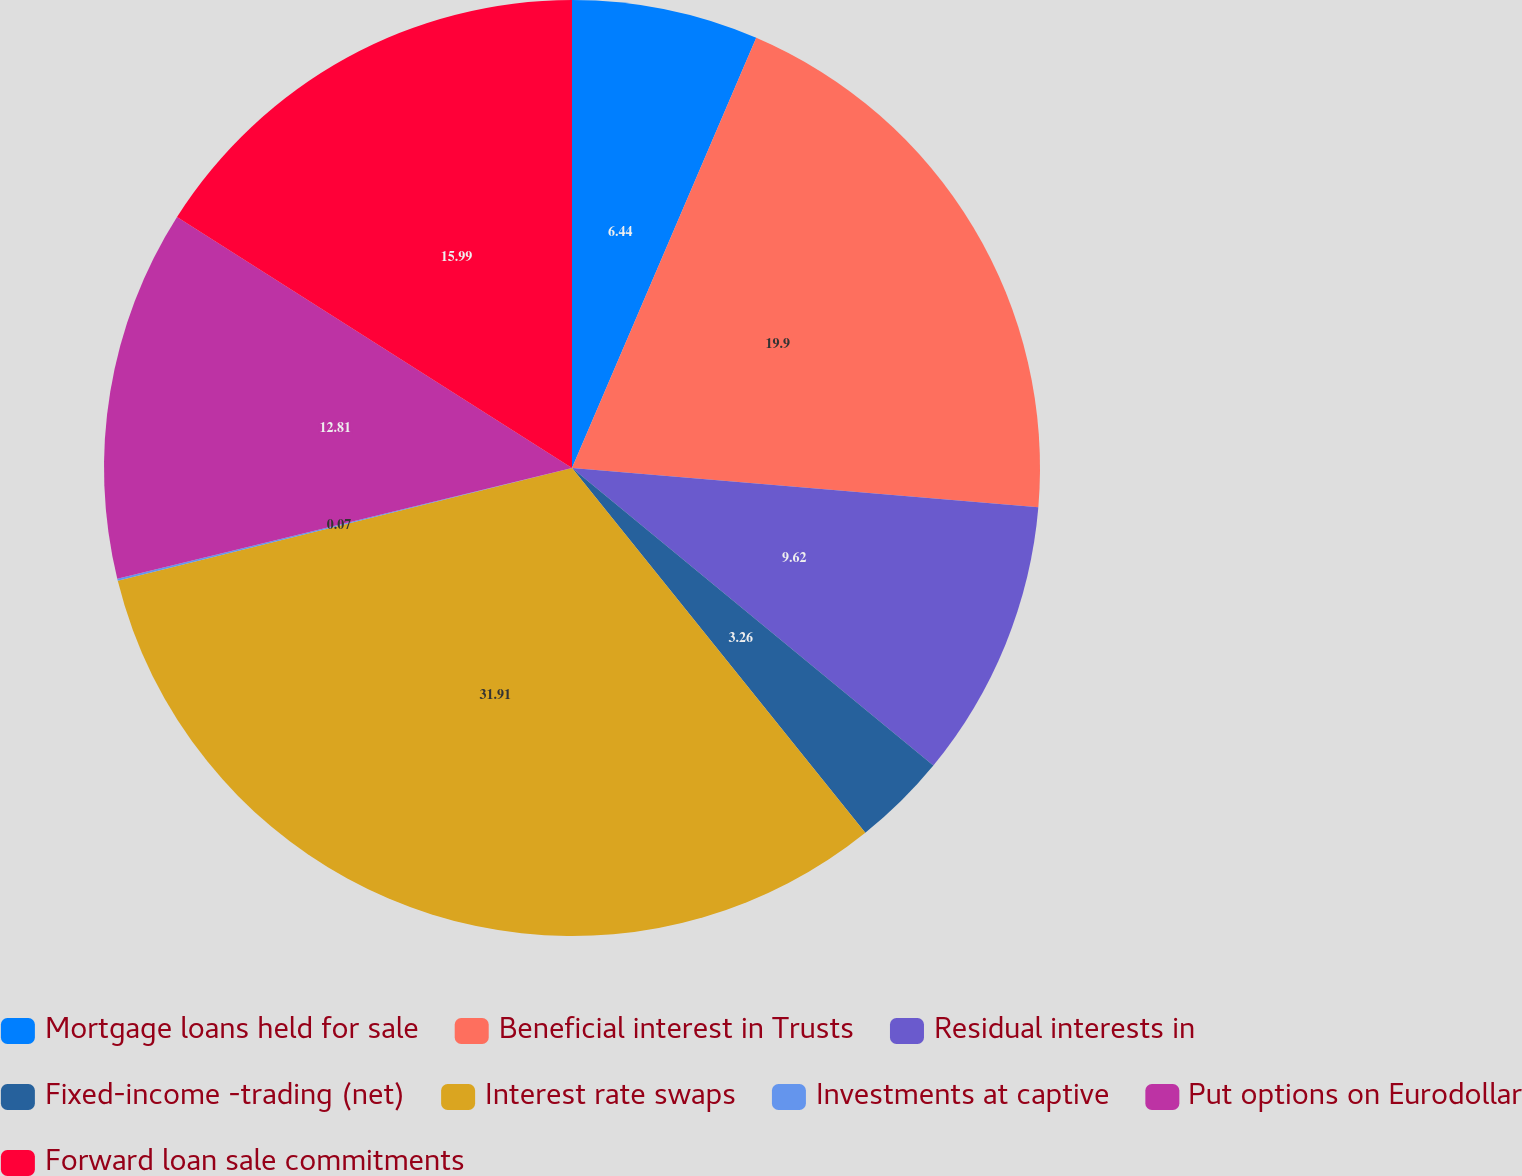Convert chart to OTSL. <chart><loc_0><loc_0><loc_500><loc_500><pie_chart><fcel>Mortgage loans held for sale<fcel>Beneficial interest in Trusts<fcel>Residual interests in<fcel>Fixed-income -trading (net)<fcel>Interest rate swaps<fcel>Investments at captive<fcel>Put options on Eurodollar<fcel>Forward loan sale commitments<nl><fcel>6.44%<fcel>19.9%<fcel>9.62%<fcel>3.26%<fcel>31.91%<fcel>0.07%<fcel>12.81%<fcel>15.99%<nl></chart> 